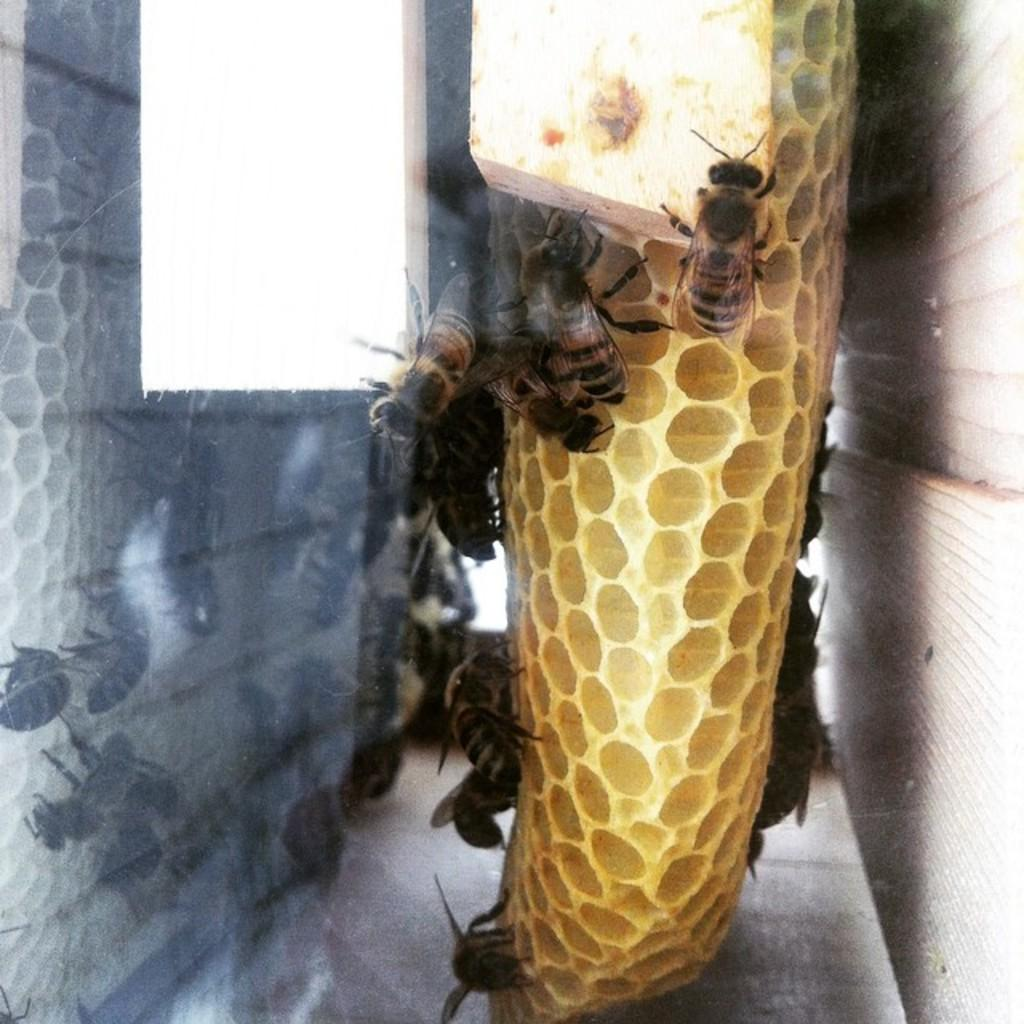What is the main subject in the center of the image? There is a beehive in the center of the image. What can be seen around the beehive? There are bees around the beehive. Where is the grandfather sitting during the meeting in the image? There is no meeting or grandfather present in the image; it features a beehive with bees around it. 